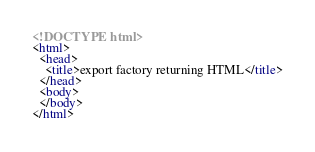<code> <loc_0><loc_0><loc_500><loc_500><_HTML_><!DOCTYPE html>
<html>
  <head>
    <title>export factory returning HTML</title>
  </head>
  <body>
  </body>
</html>
</code> 